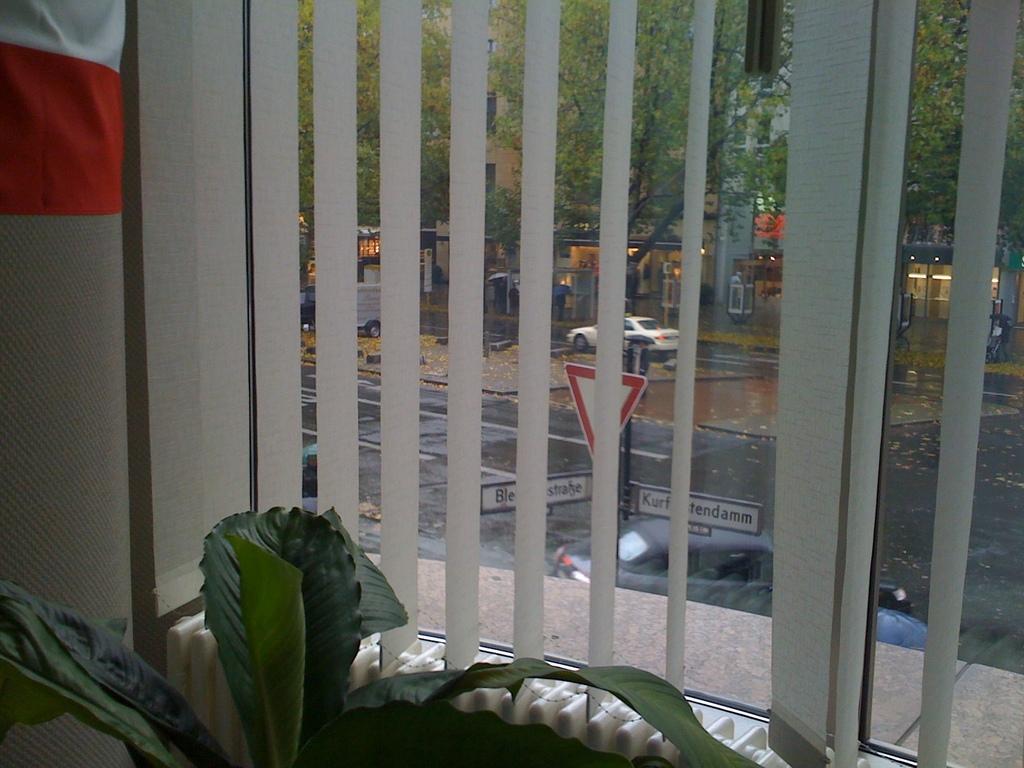How would you summarize this image in a sentence or two? On the left side, there is a plant having green color leaves. On the top left, there is a cloth. Inside this place, there is a glass window having a curtain. Through this glass window, we can see there are vehicles on the road, there are sign boards attached to a pole, there are trees and there are other objects. 